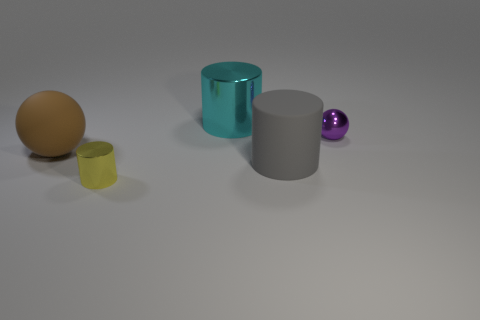Add 1 big cyan metallic objects. How many objects exist? 6 Subtract all spheres. How many objects are left? 3 Subtract 1 yellow cylinders. How many objects are left? 4 Subtract all purple shiny balls. Subtract all big objects. How many objects are left? 1 Add 5 brown matte spheres. How many brown matte spheres are left? 6 Add 3 cyan blocks. How many cyan blocks exist? 3 